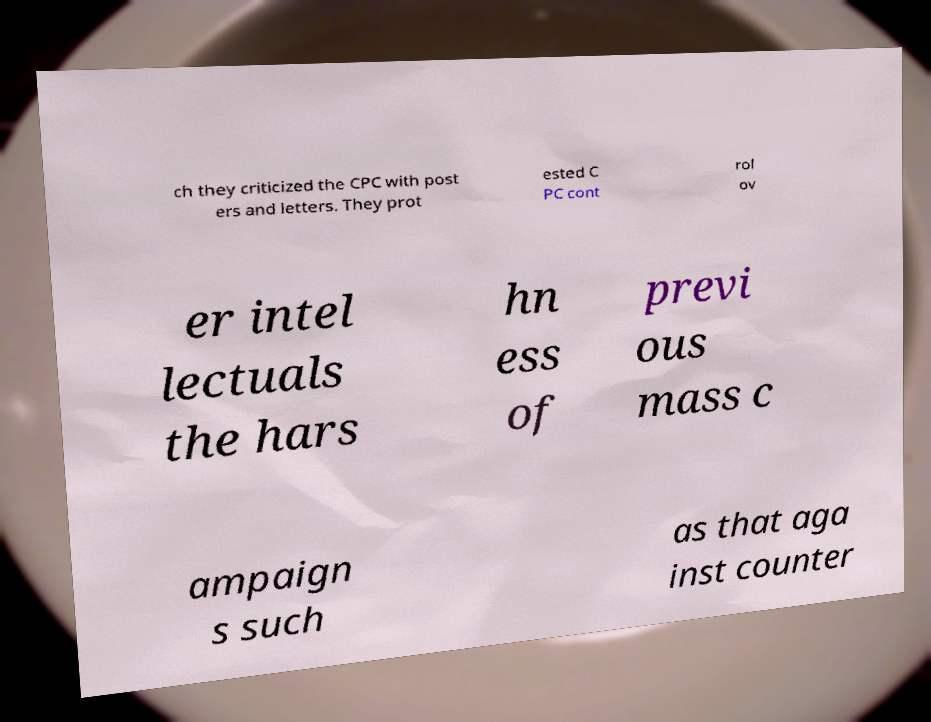I need the written content from this picture converted into text. Can you do that? ch they criticized the CPC with post ers and letters. They prot ested C PC cont rol ov er intel lectuals the hars hn ess of previ ous mass c ampaign s such as that aga inst counter 